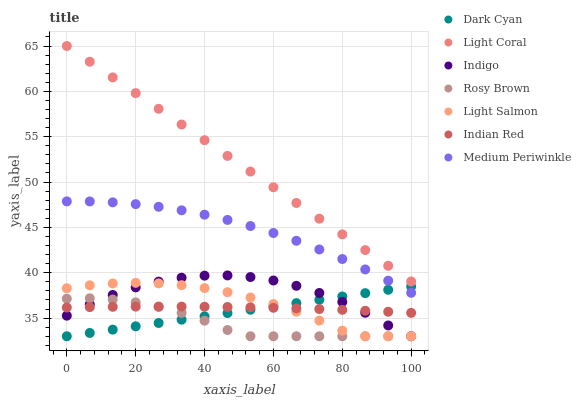Does Rosy Brown have the minimum area under the curve?
Answer yes or no. Yes. Does Light Coral have the maximum area under the curve?
Answer yes or no. Yes. Does Indigo have the minimum area under the curve?
Answer yes or no. No. Does Indigo have the maximum area under the curve?
Answer yes or no. No. Is Dark Cyan the smoothest?
Answer yes or no. Yes. Is Indigo the roughest?
Answer yes or no. Yes. Is Rosy Brown the smoothest?
Answer yes or no. No. Is Rosy Brown the roughest?
Answer yes or no. No. Does Light Salmon have the lowest value?
Answer yes or no. Yes. Does Medium Periwinkle have the lowest value?
Answer yes or no. No. Does Light Coral have the highest value?
Answer yes or no. Yes. Does Indigo have the highest value?
Answer yes or no. No. Is Indian Red less than Light Coral?
Answer yes or no. Yes. Is Light Coral greater than Light Salmon?
Answer yes or no. Yes. Does Rosy Brown intersect Indian Red?
Answer yes or no. Yes. Is Rosy Brown less than Indian Red?
Answer yes or no. No. Is Rosy Brown greater than Indian Red?
Answer yes or no. No. Does Indian Red intersect Light Coral?
Answer yes or no. No. 